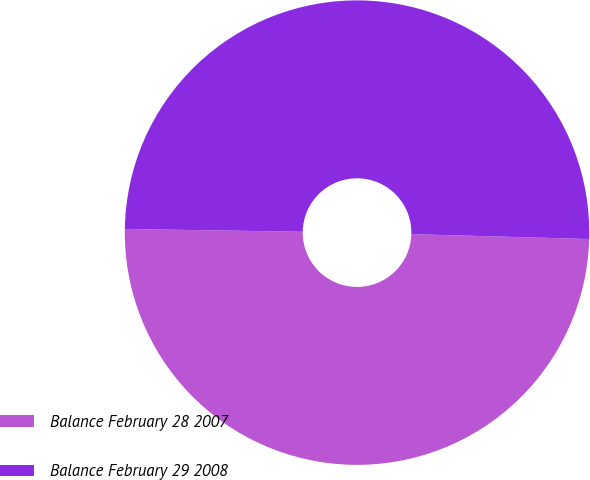<chart> <loc_0><loc_0><loc_500><loc_500><pie_chart><fcel>Balance February 28 2007<fcel>Balance February 29 2008<nl><fcel>49.81%<fcel>50.19%<nl></chart> 